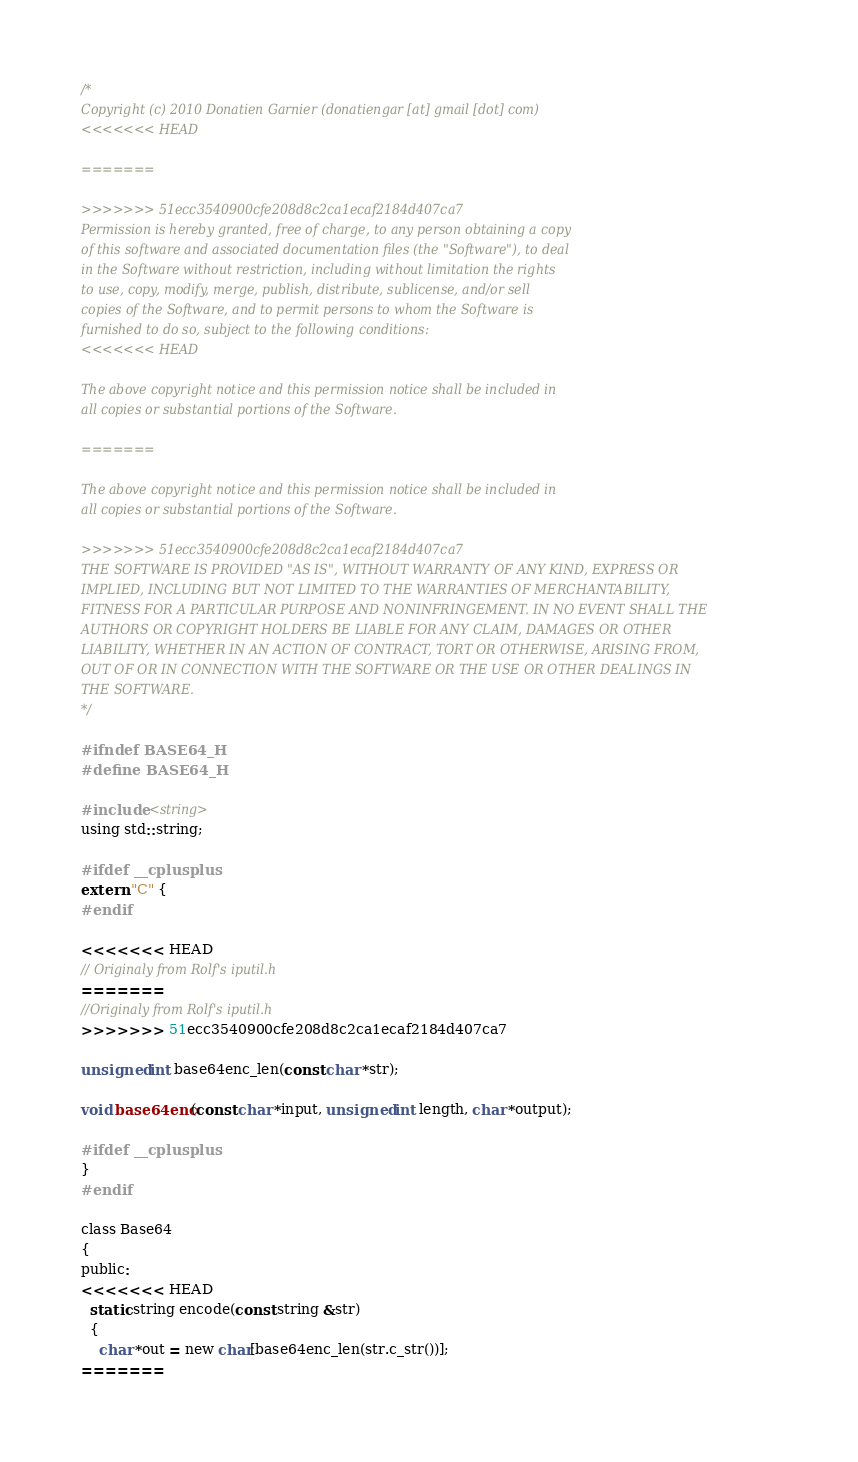Convert code to text. <code><loc_0><loc_0><loc_500><loc_500><_C_>
/*
Copyright (c) 2010 Donatien Garnier (donatiengar [at] gmail [dot] com)
<<<<<<< HEAD

=======
 
>>>>>>> 51ecc3540900cfe208d8c2ca1ecaf2184d407ca7
Permission is hereby granted, free of charge, to any person obtaining a copy
of this software and associated documentation files (the "Software"), to deal
in the Software without restriction, including without limitation the rights
to use, copy, modify, merge, publish, distribute, sublicense, and/or sell
copies of the Software, and to permit persons to whom the Software is
furnished to do so, subject to the following conditions:
<<<<<<< HEAD

The above copyright notice and this permission notice shall be included in
all copies or substantial portions of the Software.

=======
 
The above copyright notice and this permission notice shall be included in
all copies or substantial portions of the Software.
 
>>>>>>> 51ecc3540900cfe208d8c2ca1ecaf2184d407ca7
THE SOFTWARE IS PROVIDED "AS IS", WITHOUT WARRANTY OF ANY KIND, EXPRESS OR
IMPLIED, INCLUDING BUT NOT LIMITED TO THE WARRANTIES OF MERCHANTABILITY,
FITNESS FOR A PARTICULAR PURPOSE AND NONINFRINGEMENT. IN NO EVENT SHALL THE
AUTHORS OR COPYRIGHT HOLDERS BE LIABLE FOR ANY CLAIM, DAMAGES OR OTHER
LIABILITY, WHETHER IN AN ACTION OF CONTRACT, TORT OR OTHERWISE, ARISING FROM,
OUT OF OR IN CONNECTION WITH THE SOFTWARE OR THE USE OR OTHER DEALINGS IN
THE SOFTWARE.
*/

#ifndef BASE64_H
#define BASE64_H

#include <string>
using std::string;

#ifdef __cplusplus
extern "C" {
#endif

<<<<<<< HEAD
// Originaly from Rolf's iputil.h
=======
//Originaly from Rolf's iputil.h
>>>>>>> 51ecc3540900cfe208d8c2ca1ecaf2184d407ca7

unsigned int base64enc_len(const char *str);

void base64enc(const char *input, unsigned int length, char *output);

#ifdef __cplusplus
}
#endif

class Base64
{
public:
<<<<<<< HEAD
  static string encode(const string &str)
  {
    char *out = new char[base64enc_len(str.c_str())];
=======</code> 